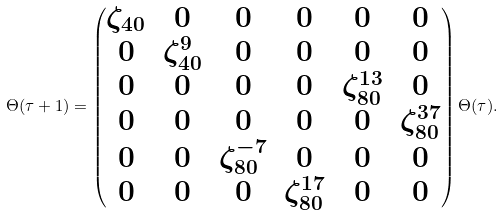<formula> <loc_0><loc_0><loc_500><loc_500>\Theta ( \tau + 1 ) = \begin{pmatrix} \zeta _ { 4 0 } & 0 & 0 & 0 & 0 & 0 \\ 0 & \zeta _ { 4 0 } ^ { 9 } & 0 & 0 & 0 & 0 \\ 0 & 0 & 0 & 0 & \zeta _ { 8 0 } ^ { 1 3 } & 0 \\ 0 & 0 & 0 & 0 & 0 & \zeta _ { 8 0 } ^ { 3 7 } \\ 0 & 0 & \zeta _ { 8 0 } ^ { - 7 } & 0 & 0 & 0 \\ 0 & 0 & 0 & \zeta _ { 8 0 } ^ { 1 7 } & 0 & 0 \end{pmatrix} \Theta ( \tau ) .</formula> 